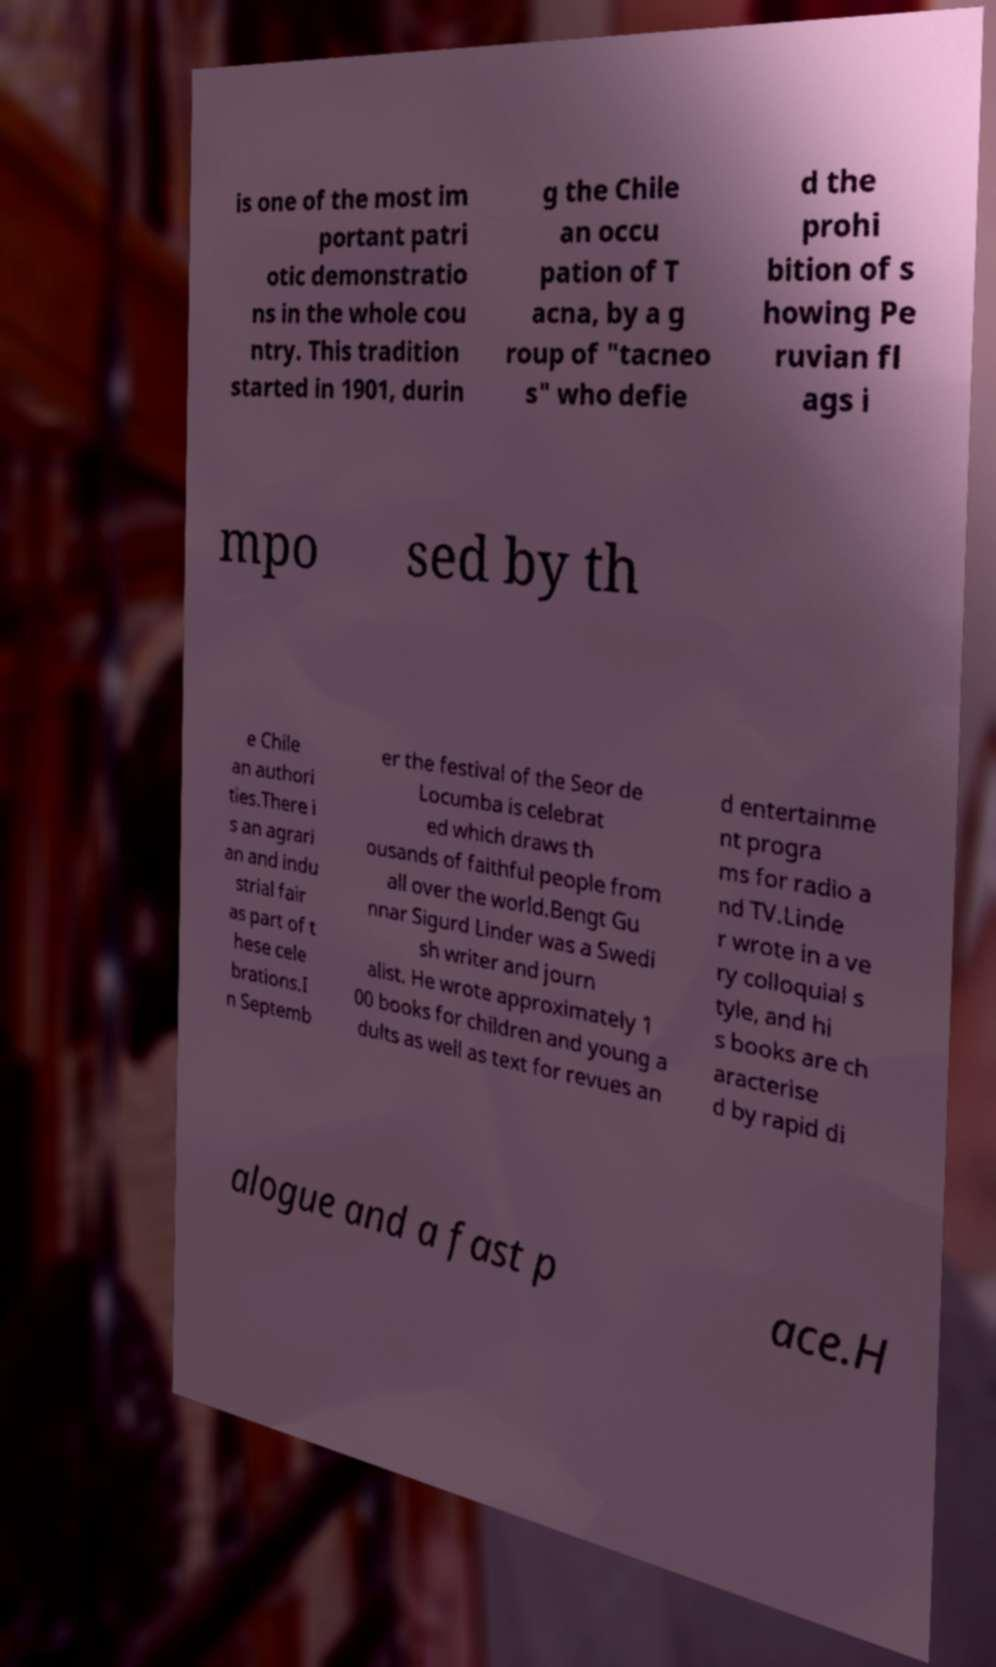Can you accurately transcribe the text from the provided image for me? is one of the most im portant patri otic demonstratio ns in the whole cou ntry. This tradition started in 1901, durin g the Chile an occu pation of T acna, by a g roup of "tacneo s" who defie d the prohi bition of s howing Pe ruvian fl ags i mpo sed by th e Chile an authori ties.There i s an agrari an and indu strial fair as part of t hese cele brations.I n Septemb er the festival of the Seor de Locumba is celebrat ed which draws th ousands of faithful people from all over the world.Bengt Gu nnar Sigurd Linder was a Swedi sh writer and journ alist. He wrote approximately 1 00 books for children and young a dults as well as text for revues an d entertainme nt progra ms for radio a nd TV.Linde r wrote in a ve ry colloquial s tyle, and hi s books are ch aracterise d by rapid di alogue and a fast p ace.H 